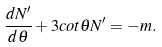Convert formula to latex. <formula><loc_0><loc_0><loc_500><loc_500>\frac { d N ^ { \prime } } { d \theta } + 3 c o t \theta N ^ { \prime } = - m .</formula> 